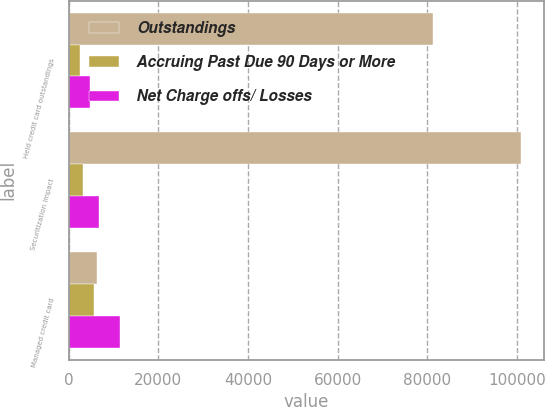<chart> <loc_0><loc_0><loc_500><loc_500><stacked_bar_chart><ecel><fcel>Held credit card outstandings<fcel>Securitization impact<fcel>Managed credit card<nl><fcel>Outstandings<fcel>81274<fcel>100960<fcel>6210<nl><fcel>Accruing Past Due 90 Days or More<fcel>2565<fcel>3185<fcel>5750<nl><fcel>Net Charge offs/ Losses<fcel>4712<fcel>6670<fcel>11382<nl></chart> 